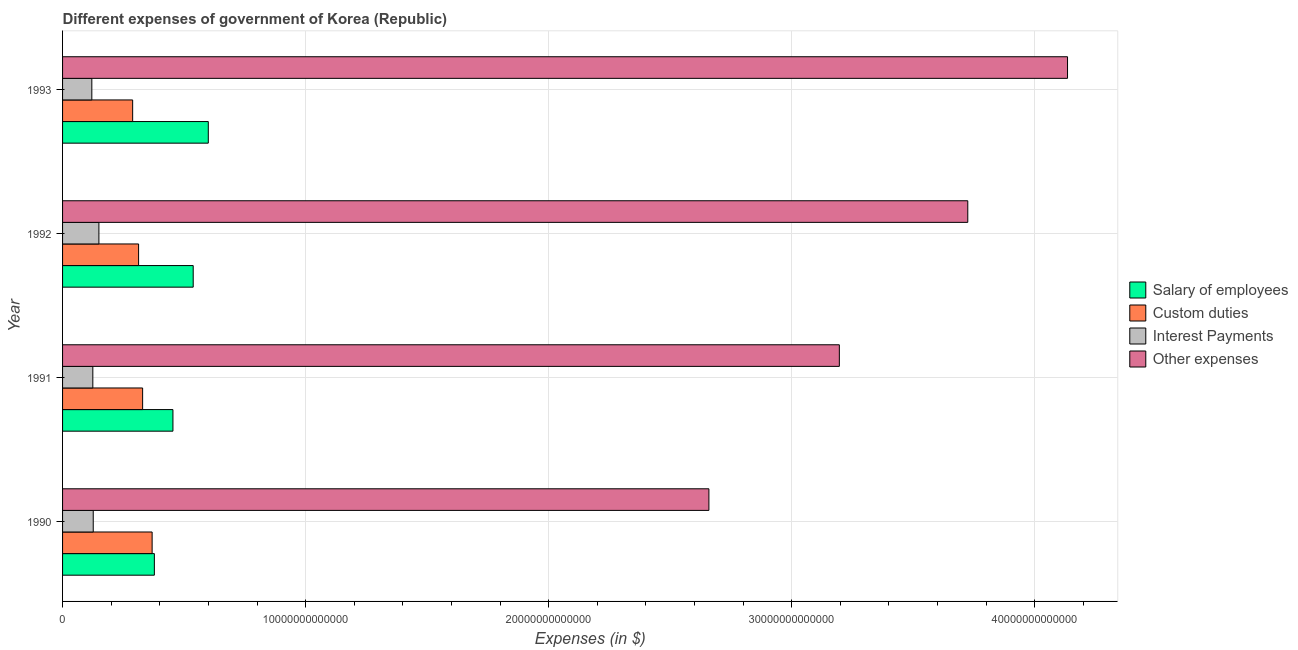How many different coloured bars are there?
Ensure brevity in your answer.  4. Are the number of bars on each tick of the Y-axis equal?
Your answer should be very brief. Yes. How many bars are there on the 2nd tick from the top?
Ensure brevity in your answer.  4. How many bars are there on the 1st tick from the bottom?
Keep it short and to the point. 4. What is the amount spent on interest payments in 1990?
Your answer should be very brief. 1.26e+12. Across all years, what is the maximum amount spent on salary of employees?
Your response must be concise. 6.00e+12. Across all years, what is the minimum amount spent on custom duties?
Offer a very short reply. 2.88e+12. In which year was the amount spent on other expenses maximum?
Offer a very short reply. 1993. What is the total amount spent on salary of employees in the graph?
Provide a short and direct response. 1.97e+13. What is the difference between the amount spent on custom duties in 1991 and that in 1992?
Your answer should be very brief. 1.66e+11. What is the difference between the amount spent on interest payments in 1991 and the amount spent on custom duties in 1993?
Your response must be concise. -1.64e+12. What is the average amount spent on other expenses per year?
Offer a very short reply. 3.43e+13. In the year 1991, what is the difference between the amount spent on custom duties and amount spent on interest payments?
Your answer should be compact. 2.05e+12. In how many years, is the amount spent on salary of employees greater than 16000000000000 $?
Your answer should be compact. 0. What is the ratio of the amount spent on other expenses in 1992 to that in 1993?
Ensure brevity in your answer.  0.9. What is the difference between the highest and the second highest amount spent on custom duties?
Ensure brevity in your answer.  3.91e+11. What is the difference between the highest and the lowest amount spent on custom duties?
Make the answer very short. 8.01e+11. Is the sum of the amount spent on interest payments in 1990 and 1991 greater than the maximum amount spent on other expenses across all years?
Offer a very short reply. No. What does the 2nd bar from the top in 1991 represents?
Your response must be concise. Interest Payments. What does the 3rd bar from the bottom in 1990 represents?
Your response must be concise. Interest Payments. How many bars are there?
Keep it short and to the point. 16. What is the difference between two consecutive major ticks on the X-axis?
Provide a short and direct response. 1.00e+13. Are the values on the major ticks of X-axis written in scientific E-notation?
Keep it short and to the point. No. Does the graph contain any zero values?
Provide a succinct answer. No. How are the legend labels stacked?
Your answer should be compact. Vertical. What is the title of the graph?
Provide a short and direct response. Different expenses of government of Korea (Republic). Does "Taxes on exports" appear as one of the legend labels in the graph?
Provide a short and direct response. No. What is the label or title of the X-axis?
Your answer should be compact. Expenses (in $). What is the Expenses (in $) of Salary of employees in 1990?
Ensure brevity in your answer.  3.78e+12. What is the Expenses (in $) of Custom duties in 1990?
Make the answer very short. 3.68e+12. What is the Expenses (in $) of Interest Payments in 1990?
Keep it short and to the point. 1.26e+12. What is the Expenses (in $) in Other expenses in 1990?
Your answer should be very brief. 2.66e+13. What is the Expenses (in $) in Salary of employees in 1991?
Keep it short and to the point. 4.54e+12. What is the Expenses (in $) of Custom duties in 1991?
Your answer should be compact. 3.29e+12. What is the Expenses (in $) of Interest Payments in 1991?
Keep it short and to the point. 1.24e+12. What is the Expenses (in $) in Other expenses in 1991?
Offer a terse response. 3.20e+13. What is the Expenses (in $) in Salary of employees in 1992?
Make the answer very short. 5.38e+12. What is the Expenses (in $) in Custom duties in 1992?
Make the answer very short. 3.13e+12. What is the Expenses (in $) in Interest Payments in 1992?
Your response must be concise. 1.50e+12. What is the Expenses (in $) in Other expenses in 1992?
Offer a terse response. 3.72e+13. What is the Expenses (in $) of Salary of employees in 1993?
Ensure brevity in your answer.  6.00e+12. What is the Expenses (in $) of Custom duties in 1993?
Give a very brief answer. 2.88e+12. What is the Expenses (in $) of Interest Payments in 1993?
Your answer should be compact. 1.20e+12. What is the Expenses (in $) in Other expenses in 1993?
Give a very brief answer. 4.13e+13. Across all years, what is the maximum Expenses (in $) in Salary of employees?
Provide a succinct answer. 6.00e+12. Across all years, what is the maximum Expenses (in $) in Custom duties?
Provide a short and direct response. 3.68e+12. Across all years, what is the maximum Expenses (in $) of Interest Payments?
Keep it short and to the point. 1.50e+12. Across all years, what is the maximum Expenses (in $) of Other expenses?
Offer a terse response. 4.13e+13. Across all years, what is the minimum Expenses (in $) in Salary of employees?
Offer a very short reply. 3.78e+12. Across all years, what is the minimum Expenses (in $) of Custom duties?
Your answer should be very brief. 2.88e+12. Across all years, what is the minimum Expenses (in $) of Interest Payments?
Make the answer very short. 1.20e+12. Across all years, what is the minimum Expenses (in $) of Other expenses?
Your response must be concise. 2.66e+13. What is the total Expenses (in $) of Salary of employees in the graph?
Keep it short and to the point. 1.97e+13. What is the total Expenses (in $) in Custom duties in the graph?
Keep it short and to the point. 1.30e+13. What is the total Expenses (in $) in Interest Payments in the graph?
Your response must be concise. 5.21e+12. What is the total Expenses (in $) in Other expenses in the graph?
Keep it short and to the point. 1.37e+14. What is the difference between the Expenses (in $) in Salary of employees in 1990 and that in 1991?
Make the answer very short. -7.64e+11. What is the difference between the Expenses (in $) of Custom duties in 1990 and that in 1991?
Offer a terse response. 3.91e+11. What is the difference between the Expenses (in $) in Interest Payments in 1990 and that in 1991?
Ensure brevity in your answer.  1.70e+1. What is the difference between the Expenses (in $) of Other expenses in 1990 and that in 1991?
Keep it short and to the point. -5.37e+12. What is the difference between the Expenses (in $) in Salary of employees in 1990 and that in 1992?
Provide a succinct answer. -1.60e+12. What is the difference between the Expenses (in $) in Custom duties in 1990 and that in 1992?
Make the answer very short. 5.57e+11. What is the difference between the Expenses (in $) in Interest Payments in 1990 and that in 1992?
Ensure brevity in your answer.  -2.33e+11. What is the difference between the Expenses (in $) of Other expenses in 1990 and that in 1992?
Provide a succinct answer. -1.07e+13. What is the difference between the Expenses (in $) in Salary of employees in 1990 and that in 1993?
Ensure brevity in your answer.  -2.22e+12. What is the difference between the Expenses (in $) in Custom duties in 1990 and that in 1993?
Your answer should be very brief. 8.01e+11. What is the difference between the Expenses (in $) of Interest Payments in 1990 and that in 1993?
Give a very brief answer. 5.80e+1. What is the difference between the Expenses (in $) of Other expenses in 1990 and that in 1993?
Offer a terse response. -1.48e+13. What is the difference between the Expenses (in $) of Salary of employees in 1991 and that in 1992?
Offer a terse response. -8.34e+11. What is the difference between the Expenses (in $) in Custom duties in 1991 and that in 1992?
Your response must be concise. 1.66e+11. What is the difference between the Expenses (in $) of Interest Payments in 1991 and that in 1992?
Offer a terse response. -2.50e+11. What is the difference between the Expenses (in $) of Other expenses in 1991 and that in 1992?
Make the answer very short. -5.28e+12. What is the difference between the Expenses (in $) in Salary of employees in 1991 and that in 1993?
Keep it short and to the point. -1.46e+12. What is the difference between the Expenses (in $) of Custom duties in 1991 and that in 1993?
Keep it short and to the point. 4.10e+11. What is the difference between the Expenses (in $) of Interest Payments in 1991 and that in 1993?
Offer a terse response. 4.10e+1. What is the difference between the Expenses (in $) in Other expenses in 1991 and that in 1993?
Give a very brief answer. -9.39e+12. What is the difference between the Expenses (in $) of Salary of employees in 1992 and that in 1993?
Give a very brief answer. -6.21e+11. What is the difference between the Expenses (in $) of Custom duties in 1992 and that in 1993?
Offer a terse response. 2.44e+11. What is the difference between the Expenses (in $) of Interest Payments in 1992 and that in 1993?
Provide a short and direct response. 2.91e+11. What is the difference between the Expenses (in $) of Other expenses in 1992 and that in 1993?
Give a very brief answer. -4.10e+12. What is the difference between the Expenses (in $) of Salary of employees in 1990 and the Expenses (in $) of Custom duties in 1991?
Your answer should be compact. 4.83e+11. What is the difference between the Expenses (in $) of Salary of employees in 1990 and the Expenses (in $) of Interest Payments in 1991?
Your response must be concise. 2.53e+12. What is the difference between the Expenses (in $) in Salary of employees in 1990 and the Expenses (in $) in Other expenses in 1991?
Make the answer very short. -2.82e+13. What is the difference between the Expenses (in $) in Custom duties in 1990 and the Expenses (in $) in Interest Payments in 1991?
Your response must be concise. 2.44e+12. What is the difference between the Expenses (in $) of Custom duties in 1990 and the Expenses (in $) of Other expenses in 1991?
Your response must be concise. -2.83e+13. What is the difference between the Expenses (in $) of Interest Payments in 1990 and the Expenses (in $) of Other expenses in 1991?
Give a very brief answer. -3.07e+13. What is the difference between the Expenses (in $) in Salary of employees in 1990 and the Expenses (in $) in Custom duties in 1992?
Offer a terse response. 6.49e+11. What is the difference between the Expenses (in $) of Salary of employees in 1990 and the Expenses (in $) of Interest Payments in 1992?
Ensure brevity in your answer.  2.28e+12. What is the difference between the Expenses (in $) of Salary of employees in 1990 and the Expenses (in $) of Other expenses in 1992?
Provide a succinct answer. -3.35e+13. What is the difference between the Expenses (in $) of Custom duties in 1990 and the Expenses (in $) of Interest Payments in 1992?
Give a very brief answer. 2.19e+12. What is the difference between the Expenses (in $) in Custom duties in 1990 and the Expenses (in $) in Other expenses in 1992?
Your response must be concise. -3.36e+13. What is the difference between the Expenses (in $) in Interest Payments in 1990 and the Expenses (in $) in Other expenses in 1992?
Your answer should be compact. -3.60e+13. What is the difference between the Expenses (in $) of Salary of employees in 1990 and the Expenses (in $) of Custom duties in 1993?
Offer a terse response. 8.93e+11. What is the difference between the Expenses (in $) of Salary of employees in 1990 and the Expenses (in $) of Interest Payments in 1993?
Provide a succinct answer. 2.57e+12. What is the difference between the Expenses (in $) of Salary of employees in 1990 and the Expenses (in $) of Other expenses in 1993?
Your answer should be very brief. -3.76e+13. What is the difference between the Expenses (in $) in Custom duties in 1990 and the Expenses (in $) in Interest Payments in 1993?
Your answer should be very brief. 2.48e+12. What is the difference between the Expenses (in $) in Custom duties in 1990 and the Expenses (in $) in Other expenses in 1993?
Give a very brief answer. -3.77e+13. What is the difference between the Expenses (in $) in Interest Payments in 1990 and the Expenses (in $) in Other expenses in 1993?
Your response must be concise. -4.01e+13. What is the difference between the Expenses (in $) in Salary of employees in 1991 and the Expenses (in $) in Custom duties in 1992?
Provide a succinct answer. 1.41e+12. What is the difference between the Expenses (in $) in Salary of employees in 1991 and the Expenses (in $) in Interest Payments in 1992?
Provide a short and direct response. 3.05e+12. What is the difference between the Expenses (in $) in Salary of employees in 1991 and the Expenses (in $) in Other expenses in 1992?
Your response must be concise. -3.27e+13. What is the difference between the Expenses (in $) of Custom duties in 1991 and the Expenses (in $) of Interest Payments in 1992?
Give a very brief answer. 1.80e+12. What is the difference between the Expenses (in $) of Custom duties in 1991 and the Expenses (in $) of Other expenses in 1992?
Offer a very short reply. -3.40e+13. What is the difference between the Expenses (in $) of Interest Payments in 1991 and the Expenses (in $) of Other expenses in 1992?
Your answer should be very brief. -3.60e+13. What is the difference between the Expenses (in $) of Salary of employees in 1991 and the Expenses (in $) of Custom duties in 1993?
Your response must be concise. 1.66e+12. What is the difference between the Expenses (in $) of Salary of employees in 1991 and the Expenses (in $) of Interest Payments in 1993?
Provide a short and direct response. 3.34e+12. What is the difference between the Expenses (in $) of Salary of employees in 1991 and the Expenses (in $) of Other expenses in 1993?
Provide a succinct answer. -3.68e+13. What is the difference between the Expenses (in $) in Custom duties in 1991 and the Expenses (in $) in Interest Payments in 1993?
Ensure brevity in your answer.  2.09e+12. What is the difference between the Expenses (in $) of Custom duties in 1991 and the Expenses (in $) of Other expenses in 1993?
Give a very brief answer. -3.81e+13. What is the difference between the Expenses (in $) of Interest Payments in 1991 and the Expenses (in $) of Other expenses in 1993?
Offer a very short reply. -4.01e+13. What is the difference between the Expenses (in $) of Salary of employees in 1992 and the Expenses (in $) of Custom duties in 1993?
Provide a short and direct response. 2.49e+12. What is the difference between the Expenses (in $) of Salary of employees in 1992 and the Expenses (in $) of Interest Payments in 1993?
Your response must be concise. 4.17e+12. What is the difference between the Expenses (in $) in Salary of employees in 1992 and the Expenses (in $) in Other expenses in 1993?
Ensure brevity in your answer.  -3.60e+13. What is the difference between the Expenses (in $) of Custom duties in 1992 and the Expenses (in $) of Interest Payments in 1993?
Offer a very short reply. 1.92e+12. What is the difference between the Expenses (in $) in Custom duties in 1992 and the Expenses (in $) in Other expenses in 1993?
Your answer should be compact. -3.82e+13. What is the difference between the Expenses (in $) in Interest Payments in 1992 and the Expenses (in $) in Other expenses in 1993?
Give a very brief answer. -3.99e+13. What is the average Expenses (in $) in Salary of employees per year?
Provide a short and direct response. 4.92e+12. What is the average Expenses (in $) in Custom duties per year?
Provide a succinct answer. 3.25e+12. What is the average Expenses (in $) of Interest Payments per year?
Your answer should be very brief. 1.30e+12. What is the average Expenses (in $) of Other expenses per year?
Ensure brevity in your answer.  3.43e+13. In the year 1990, what is the difference between the Expenses (in $) of Salary of employees and Expenses (in $) of Custom duties?
Your answer should be very brief. 9.20e+1. In the year 1990, what is the difference between the Expenses (in $) in Salary of employees and Expenses (in $) in Interest Payments?
Your response must be concise. 2.52e+12. In the year 1990, what is the difference between the Expenses (in $) of Salary of employees and Expenses (in $) of Other expenses?
Keep it short and to the point. -2.28e+13. In the year 1990, what is the difference between the Expenses (in $) of Custom duties and Expenses (in $) of Interest Payments?
Your answer should be compact. 2.42e+12. In the year 1990, what is the difference between the Expenses (in $) of Custom duties and Expenses (in $) of Other expenses?
Your response must be concise. -2.29e+13. In the year 1990, what is the difference between the Expenses (in $) in Interest Payments and Expenses (in $) in Other expenses?
Offer a very short reply. -2.53e+13. In the year 1991, what is the difference between the Expenses (in $) of Salary of employees and Expenses (in $) of Custom duties?
Your answer should be compact. 1.25e+12. In the year 1991, what is the difference between the Expenses (in $) of Salary of employees and Expenses (in $) of Interest Payments?
Keep it short and to the point. 3.30e+12. In the year 1991, what is the difference between the Expenses (in $) in Salary of employees and Expenses (in $) in Other expenses?
Give a very brief answer. -2.74e+13. In the year 1991, what is the difference between the Expenses (in $) in Custom duties and Expenses (in $) in Interest Payments?
Your response must be concise. 2.05e+12. In the year 1991, what is the difference between the Expenses (in $) of Custom duties and Expenses (in $) of Other expenses?
Your answer should be compact. -2.87e+13. In the year 1991, what is the difference between the Expenses (in $) of Interest Payments and Expenses (in $) of Other expenses?
Make the answer very short. -3.07e+13. In the year 1992, what is the difference between the Expenses (in $) in Salary of employees and Expenses (in $) in Custom duties?
Provide a succinct answer. 2.25e+12. In the year 1992, what is the difference between the Expenses (in $) in Salary of employees and Expenses (in $) in Interest Payments?
Give a very brief answer. 3.88e+12. In the year 1992, what is the difference between the Expenses (in $) in Salary of employees and Expenses (in $) in Other expenses?
Give a very brief answer. -3.19e+13. In the year 1992, what is the difference between the Expenses (in $) of Custom duties and Expenses (in $) of Interest Payments?
Make the answer very short. 1.63e+12. In the year 1992, what is the difference between the Expenses (in $) in Custom duties and Expenses (in $) in Other expenses?
Ensure brevity in your answer.  -3.41e+13. In the year 1992, what is the difference between the Expenses (in $) in Interest Payments and Expenses (in $) in Other expenses?
Offer a terse response. -3.57e+13. In the year 1993, what is the difference between the Expenses (in $) of Salary of employees and Expenses (in $) of Custom duties?
Your answer should be very brief. 3.11e+12. In the year 1993, what is the difference between the Expenses (in $) of Salary of employees and Expenses (in $) of Interest Payments?
Offer a terse response. 4.79e+12. In the year 1993, what is the difference between the Expenses (in $) of Salary of employees and Expenses (in $) of Other expenses?
Give a very brief answer. -3.54e+13. In the year 1993, what is the difference between the Expenses (in $) of Custom duties and Expenses (in $) of Interest Payments?
Ensure brevity in your answer.  1.68e+12. In the year 1993, what is the difference between the Expenses (in $) of Custom duties and Expenses (in $) of Other expenses?
Your response must be concise. -3.85e+13. In the year 1993, what is the difference between the Expenses (in $) in Interest Payments and Expenses (in $) in Other expenses?
Provide a short and direct response. -4.01e+13. What is the ratio of the Expenses (in $) of Salary of employees in 1990 to that in 1991?
Keep it short and to the point. 0.83. What is the ratio of the Expenses (in $) in Custom duties in 1990 to that in 1991?
Your response must be concise. 1.12. What is the ratio of the Expenses (in $) in Interest Payments in 1990 to that in 1991?
Provide a short and direct response. 1.01. What is the ratio of the Expenses (in $) of Other expenses in 1990 to that in 1991?
Provide a succinct answer. 0.83. What is the ratio of the Expenses (in $) in Salary of employees in 1990 to that in 1992?
Provide a succinct answer. 0.7. What is the ratio of the Expenses (in $) in Custom duties in 1990 to that in 1992?
Your answer should be very brief. 1.18. What is the ratio of the Expenses (in $) in Interest Payments in 1990 to that in 1992?
Provide a short and direct response. 0.84. What is the ratio of the Expenses (in $) in Other expenses in 1990 to that in 1992?
Your answer should be compact. 0.71. What is the ratio of the Expenses (in $) in Salary of employees in 1990 to that in 1993?
Provide a short and direct response. 0.63. What is the ratio of the Expenses (in $) in Custom duties in 1990 to that in 1993?
Your response must be concise. 1.28. What is the ratio of the Expenses (in $) in Interest Payments in 1990 to that in 1993?
Make the answer very short. 1.05. What is the ratio of the Expenses (in $) in Other expenses in 1990 to that in 1993?
Give a very brief answer. 0.64. What is the ratio of the Expenses (in $) in Salary of employees in 1991 to that in 1992?
Your answer should be compact. 0.84. What is the ratio of the Expenses (in $) of Custom duties in 1991 to that in 1992?
Your response must be concise. 1.05. What is the ratio of the Expenses (in $) of Interest Payments in 1991 to that in 1992?
Provide a succinct answer. 0.83. What is the ratio of the Expenses (in $) in Other expenses in 1991 to that in 1992?
Your response must be concise. 0.86. What is the ratio of the Expenses (in $) of Salary of employees in 1991 to that in 1993?
Make the answer very short. 0.76. What is the ratio of the Expenses (in $) in Custom duties in 1991 to that in 1993?
Offer a terse response. 1.14. What is the ratio of the Expenses (in $) of Interest Payments in 1991 to that in 1993?
Your answer should be compact. 1.03. What is the ratio of the Expenses (in $) of Other expenses in 1991 to that in 1993?
Keep it short and to the point. 0.77. What is the ratio of the Expenses (in $) in Salary of employees in 1992 to that in 1993?
Your response must be concise. 0.9. What is the ratio of the Expenses (in $) of Custom duties in 1992 to that in 1993?
Provide a short and direct response. 1.08. What is the ratio of the Expenses (in $) in Interest Payments in 1992 to that in 1993?
Your answer should be very brief. 1.24. What is the ratio of the Expenses (in $) in Other expenses in 1992 to that in 1993?
Ensure brevity in your answer.  0.9. What is the difference between the highest and the second highest Expenses (in $) of Salary of employees?
Your answer should be very brief. 6.21e+11. What is the difference between the highest and the second highest Expenses (in $) of Custom duties?
Your answer should be very brief. 3.91e+11. What is the difference between the highest and the second highest Expenses (in $) in Interest Payments?
Keep it short and to the point. 2.33e+11. What is the difference between the highest and the second highest Expenses (in $) of Other expenses?
Make the answer very short. 4.10e+12. What is the difference between the highest and the lowest Expenses (in $) in Salary of employees?
Keep it short and to the point. 2.22e+12. What is the difference between the highest and the lowest Expenses (in $) in Custom duties?
Keep it short and to the point. 8.01e+11. What is the difference between the highest and the lowest Expenses (in $) in Interest Payments?
Your response must be concise. 2.91e+11. What is the difference between the highest and the lowest Expenses (in $) of Other expenses?
Your response must be concise. 1.48e+13. 